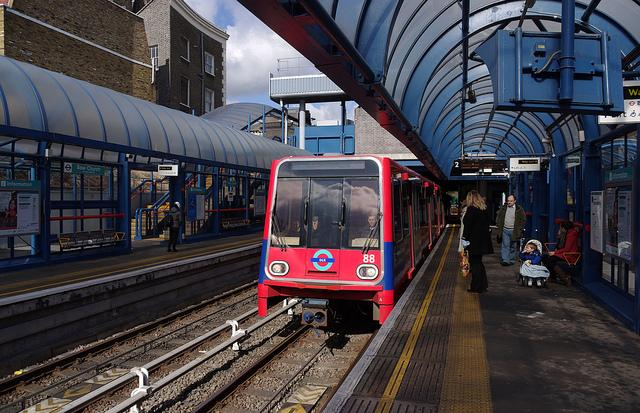Why are they all looking at the train?

Choices:
A) fearful
B) want ride
C) annoyed
D) like colors want ride 